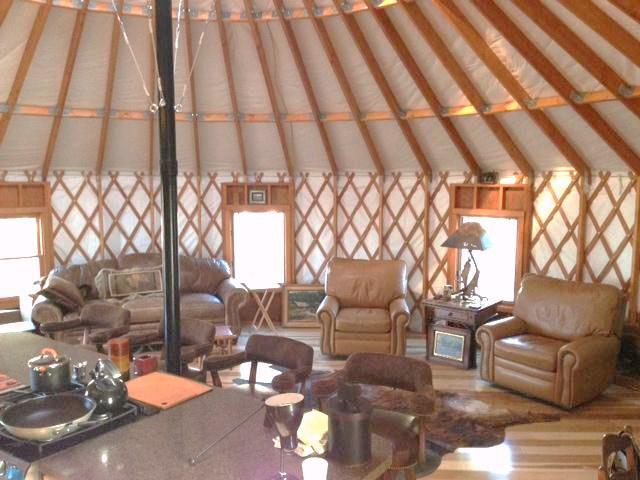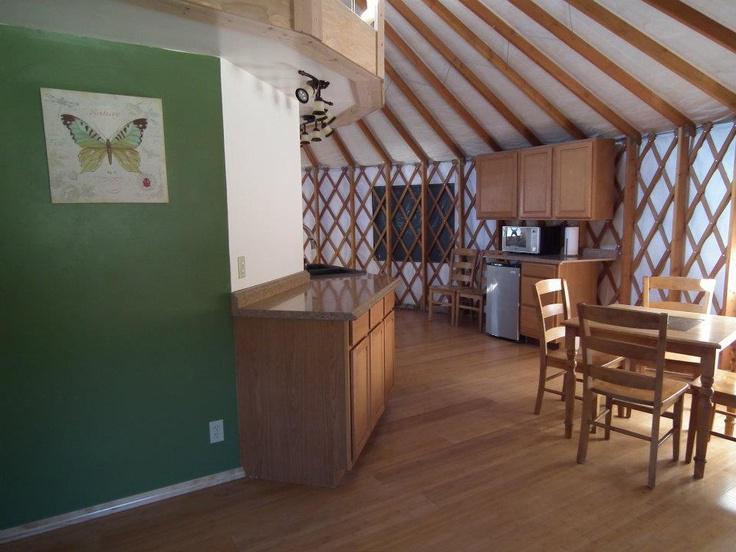The first image is the image on the left, the second image is the image on the right. Given the left and right images, does the statement "One of the images is of a bedroom." hold true? Answer yes or no. No. 